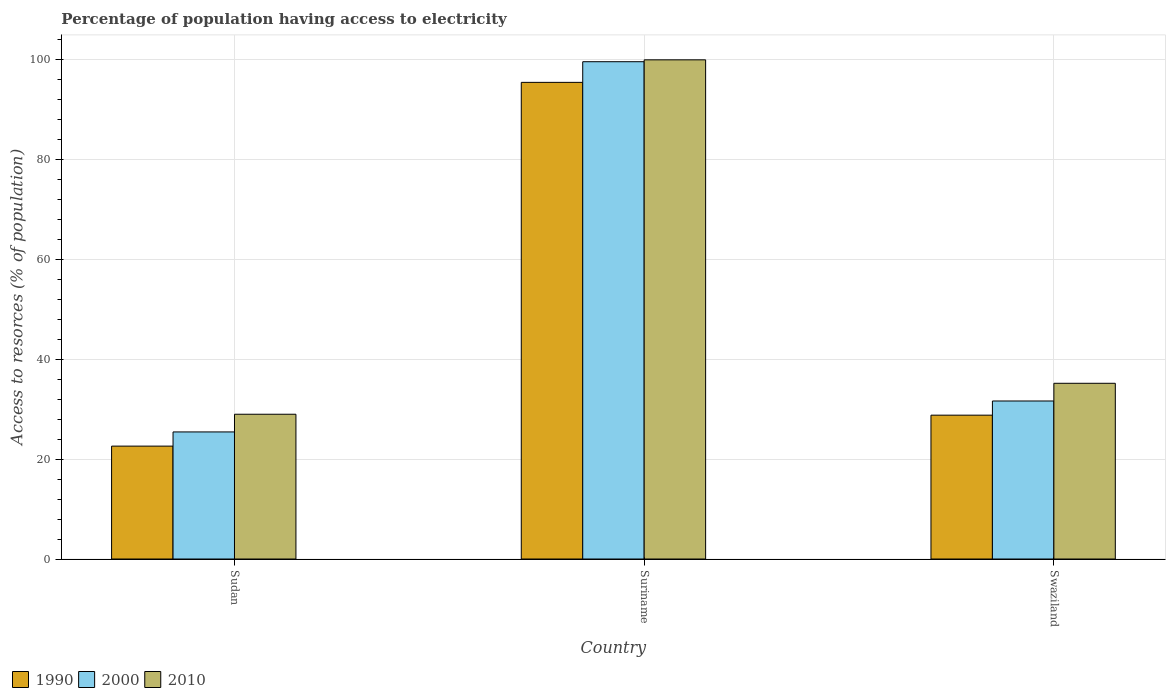How many bars are there on the 1st tick from the right?
Your answer should be very brief. 3. What is the label of the 2nd group of bars from the left?
Keep it short and to the point. Suriname. In how many cases, is the number of bars for a given country not equal to the number of legend labels?
Your answer should be very brief. 0. What is the percentage of population having access to electricity in 2000 in Suriname?
Offer a terse response. 99.62. Across all countries, what is the maximum percentage of population having access to electricity in 2010?
Make the answer very short. 100. Across all countries, what is the minimum percentage of population having access to electricity in 2000?
Provide a short and direct response. 25.46. In which country was the percentage of population having access to electricity in 2010 maximum?
Provide a succinct answer. Suriname. In which country was the percentage of population having access to electricity in 2010 minimum?
Offer a terse response. Sudan. What is the total percentage of population having access to electricity in 2010 in the graph?
Keep it short and to the point. 164.2. What is the difference between the percentage of population having access to electricity in 2010 in Sudan and that in Swaziland?
Your answer should be very brief. -6.2. What is the difference between the percentage of population having access to electricity in 2000 in Sudan and the percentage of population having access to electricity in 2010 in Swaziland?
Give a very brief answer. -9.74. What is the average percentage of population having access to electricity in 2010 per country?
Offer a very short reply. 54.73. What is the difference between the percentage of population having access to electricity of/in 1990 and percentage of population having access to electricity of/in 2010 in Sudan?
Provide a short and direct response. -6.38. In how many countries, is the percentage of population having access to electricity in 1990 greater than 4 %?
Provide a succinct answer. 3. What is the ratio of the percentage of population having access to electricity in 1990 in Suriname to that in Swaziland?
Make the answer very short. 3.31. Is the difference between the percentage of population having access to electricity in 1990 in Sudan and Suriname greater than the difference between the percentage of population having access to electricity in 2010 in Sudan and Suriname?
Make the answer very short. No. What is the difference between the highest and the second highest percentage of population having access to electricity in 2000?
Offer a terse response. -74.17. What is the difference between the highest and the lowest percentage of population having access to electricity in 1990?
Give a very brief answer. 72.87. In how many countries, is the percentage of population having access to electricity in 2010 greater than the average percentage of population having access to electricity in 2010 taken over all countries?
Your answer should be very brief. 1. Is the sum of the percentage of population having access to electricity in 2010 in Sudan and Suriname greater than the maximum percentage of population having access to electricity in 2000 across all countries?
Your answer should be very brief. Yes. What does the 3rd bar from the left in Suriname represents?
Make the answer very short. 2010. Is it the case that in every country, the sum of the percentage of population having access to electricity in 1990 and percentage of population having access to electricity in 2010 is greater than the percentage of population having access to electricity in 2000?
Give a very brief answer. Yes. How many bars are there?
Your answer should be very brief. 9. How many countries are there in the graph?
Your response must be concise. 3. Are the values on the major ticks of Y-axis written in scientific E-notation?
Provide a short and direct response. No. Does the graph contain any zero values?
Your answer should be very brief. No. Does the graph contain grids?
Make the answer very short. Yes. Where does the legend appear in the graph?
Provide a short and direct response. Bottom left. How many legend labels are there?
Make the answer very short. 3. How are the legend labels stacked?
Your response must be concise. Horizontal. What is the title of the graph?
Make the answer very short. Percentage of population having access to electricity. Does "1960" appear as one of the legend labels in the graph?
Your response must be concise. No. What is the label or title of the Y-axis?
Offer a very short reply. Access to resorces (% of population). What is the Access to resorces (% of population) in 1990 in Sudan?
Your answer should be compact. 22.62. What is the Access to resorces (% of population) of 2000 in Sudan?
Provide a short and direct response. 25.46. What is the Access to resorces (% of population) in 2010 in Sudan?
Offer a very short reply. 29. What is the Access to resorces (% of population) of 1990 in Suriname?
Offer a very short reply. 95.49. What is the Access to resorces (% of population) of 2000 in Suriname?
Give a very brief answer. 99.62. What is the Access to resorces (% of population) of 1990 in Swaziland?
Make the answer very short. 28.82. What is the Access to resorces (% of population) in 2000 in Swaziland?
Offer a very short reply. 31.66. What is the Access to resorces (% of population) of 2010 in Swaziland?
Give a very brief answer. 35.2. Across all countries, what is the maximum Access to resorces (% of population) of 1990?
Make the answer very short. 95.49. Across all countries, what is the maximum Access to resorces (% of population) of 2000?
Your response must be concise. 99.62. Across all countries, what is the maximum Access to resorces (% of population) of 2010?
Your answer should be compact. 100. Across all countries, what is the minimum Access to resorces (% of population) of 1990?
Offer a terse response. 22.62. Across all countries, what is the minimum Access to resorces (% of population) in 2000?
Your answer should be very brief. 25.46. Across all countries, what is the minimum Access to resorces (% of population) of 2010?
Give a very brief answer. 29. What is the total Access to resorces (% of population) in 1990 in the graph?
Ensure brevity in your answer.  146.92. What is the total Access to resorces (% of population) in 2000 in the graph?
Provide a short and direct response. 156.74. What is the total Access to resorces (% of population) in 2010 in the graph?
Your response must be concise. 164.2. What is the difference between the Access to resorces (% of population) in 1990 in Sudan and that in Suriname?
Offer a very short reply. -72.87. What is the difference between the Access to resorces (% of population) in 2000 in Sudan and that in Suriname?
Make the answer very short. -74.17. What is the difference between the Access to resorces (% of population) in 2010 in Sudan and that in Suriname?
Provide a succinct answer. -71. What is the difference between the Access to resorces (% of population) of 2000 in Sudan and that in Swaziland?
Provide a succinct answer. -6.2. What is the difference between the Access to resorces (% of population) of 1990 in Suriname and that in Swaziland?
Provide a succinct answer. 66.67. What is the difference between the Access to resorces (% of population) in 2000 in Suriname and that in Swaziland?
Give a very brief answer. 67.97. What is the difference between the Access to resorces (% of population) of 2010 in Suriname and that in Swaziland?
Offer a very short reply. 64.8. What is the difference between the Access to resorces (% of population) in 1990 in Sudan and the Access to resorces (% of population) in 2000 in Suriname?
Make the answer very short. -77.01. What is the difference between the Access to resorces (% of population) in 1990 in Sudan and the Access to resorces (% of population) in 2010 in Suriname?
Your answer should be compact. -77.38. What is the difference between the Access to resorces (% of population) in 2000 in Sudan and the Access to resorces (% of population) in 2010 in Suriname?
Make the answer very short. -74.54. What is the difference between the Access to resorces (% of population) in 1990 in Sudan and the Access to resorces (% of population) in 2000 in Swaziland?
Offer a very short reply. -9.04. What is the difference between the Access to resorces (% of population) of 1990 in Sudan and the Access to resorces (% of population) of 2010 in Swaziland?
Your answer should be compact. -12.58. What is the difference between the Access to resorces (% of population) of 2000 in Sudan and the Access to resorces (% of population) of 2010 in Swaziland?
Your answer should be very brief. -9.74. What is the difference between the Access to resorces (% of population) of 1990 in Suriname and the Access to resorces (% of population) of 2000 in Swaziland?
Keep it short and to the point. 63.83. What is the difference between the Access to resorces (% of population) of 1990 in Suriname and the Access to resorces (% of population) of 2010 in Swaziland?
Provide a succinct answer. 60.29. What is the difference between the Access to resorces (% of population) in 2000 in Suriname and the Access to resorces (% of population) in 2010 in Swaziland?
Ensure brevity in your answer.  64.42. What is the average Access to resorces (% of population) in 1990 per country?
Your answer should be very brief. 48.97. What is the average Access to resorces (% of population) in 2000 per country?
Your answer should be very brief. 52.25. What is the average Access to resorces (% of population) of 2010 per country?
Your answer should be very brief. 54.73. What is the difference between the Access to resorces (% of population) in 1990 and Access to resorces (% of population) in 2000 in Sudan?
Ensure brevity in your answer.  -2.84. What is the difference between the Access to resorces (% of population) in 1990 and Access to resorces (% of population) in 2010 in Sudan?
Ensure brevity in your answer.  -6.38. What is the difference between the Access to resorces (% of population) in 2000 and Access to resorces (% of population) in 2010 in Sudan?
Your answer should be compact. -3.54. What is the difference between the Access to resorces (% of population) in 1990 and Access to resorces (% of population) in 2000 in Suriname?
Your answer should be compact. -4.14. What is the difference between the Access to resorces (% of population) of 1990 and Access to resorces (% of population) of 2010 in Suriname?
Your answer should be very brief. -4.51. What is the difference between the Access to resorces (% of population) of 2000 and Access to resorces (% of population) of 2010 in Suriname?
Give a very brief answer. -0.38. What is the difference between the Access to resorces (% of population) of 1990 and Access to resorces (% of population) of 2000 in Swaziland?
Your response must be concise. -2.84. What is the difference between the Access to resorces (% of population) in 1990 and Access to resorces (% of population) in 2010 in Swaziland?
Ensure brevity in your answer.  -6.38. What is the difference between the Access to resorces (% of population) in 2000 and Access to resorces (% of population) in 2010 in Swaziland?
Make the answer very short. -3.54. What is the ratio of the Access to resorces (% of population) of 1990 in Sudan to that in Suriname?
Your answer should be compact. 0.24. What is the ratio of the Access to resorces (% of population) in 2000 in Sudan to that in Suriname?
Give a very brief answer. 0.26. What is the ratio of the Access to resorces (% of population) of 2010 in Sudan to that in Suriname?
Make the answer very short. 0.29. What is the ratio of the Access to resorces (% of population) of 1990 in Sudan to that in Swaziland?
Offer a very short reply. 0.78. What is the ratio of the Access to resorces (% of population) of 2000 in Sudan to that in Swaziland?
Provide a succinct answer. 0.8. What is the ratio of the Access to resorces (% of population) of 2010 in Sudan to that in Swaziland?
Give a very brief answer. 0.82. What is the ratio of the Access to resorces (% of population) in 1990 in Suriname to that in Swaziland?
Keep it short and to the point. 3.31. What is the ratio of the Access to resorces (% of population) in 2000 in Suriname to that in Swaziland?
Your answer should be very brief. 3.15. What is the ratio of the Access to resorces (% of population) of 2010 in Suriname to that in Swaziland?
Your response must be concise. 2.84. What is the difference between the highest and the second highest Access to resorces (% of population) of 1990?
Offer a very short reply. 66.67. What is the difference between the highest and the second highest Access to resorces (% of population) of 2000?
Keep it short and to the point. 67.97. What is the difference between the highest and the second highest Access to resorces (% of population) in 2010?
Your response must be concise. 64.8. What is the difference between the highest and the lowest Access to resorces (% of population) of 1990?
Keep it short and to the point. 72.87. What is the difference between the highest and the lowest Access to resorces (% of population) in 2000?
Your response must be concise. 74.17. 